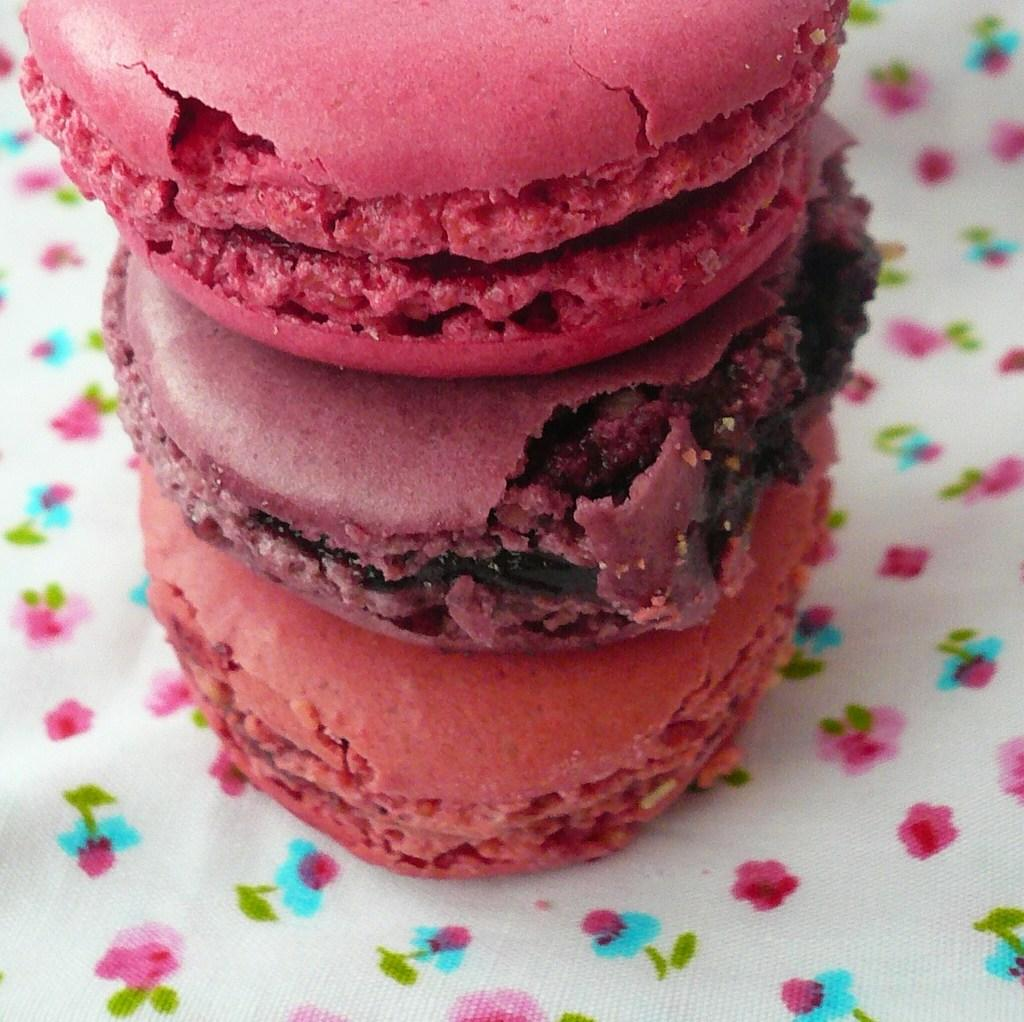What type of food is present in the image? The image contains cakes in different colors. What is located at the bottom of the image? There is a cloth at the bottom of the image. What type of chalk is used to draw on the cakes in the image? There is no chalk present in the image, and the cakes are not being drawn on. 